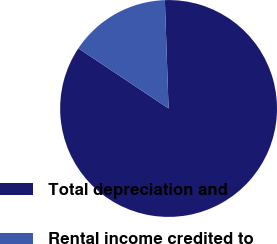Convert chart to OTSL. <chart><loc_0><loc_0><loc_500><loc_500><pie_chart><fcel>Total depreciation and<fcel>Rental income credited to<nl><fcel>84.9%<fcel>15.1%<nl></chart> 